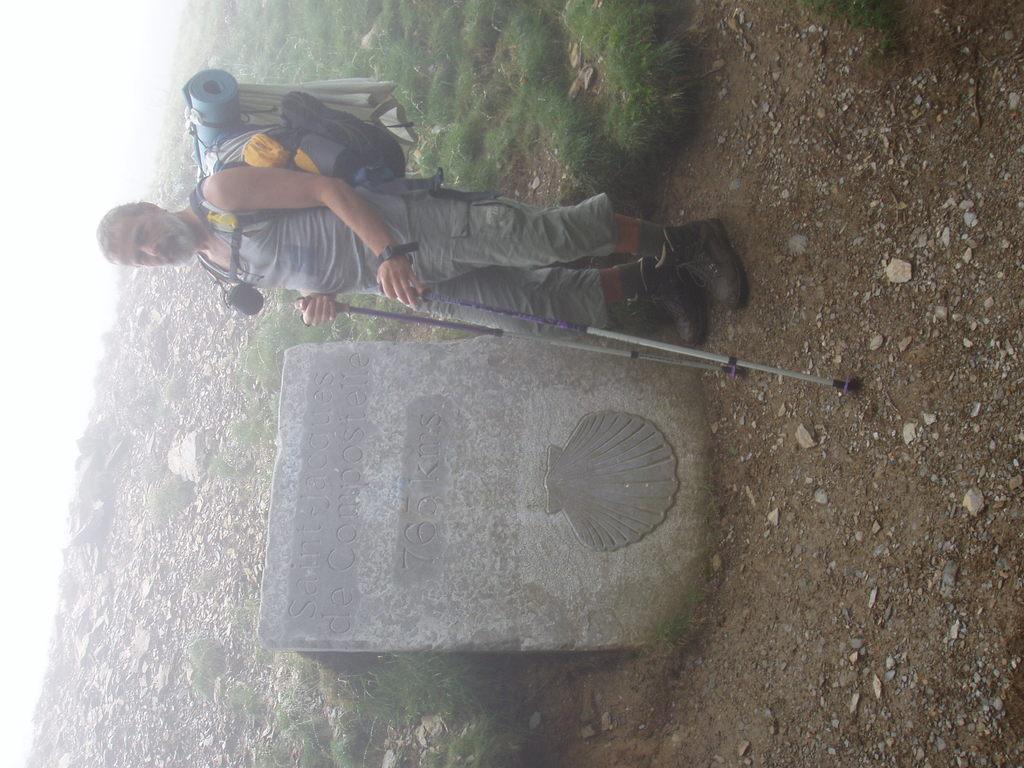Describe this image in one or two sentences. In this image we can see a person wearing a bag and holding few objects. There is a grassy land in the image. There are many stones in the image. There is a memorial stone in the image. 